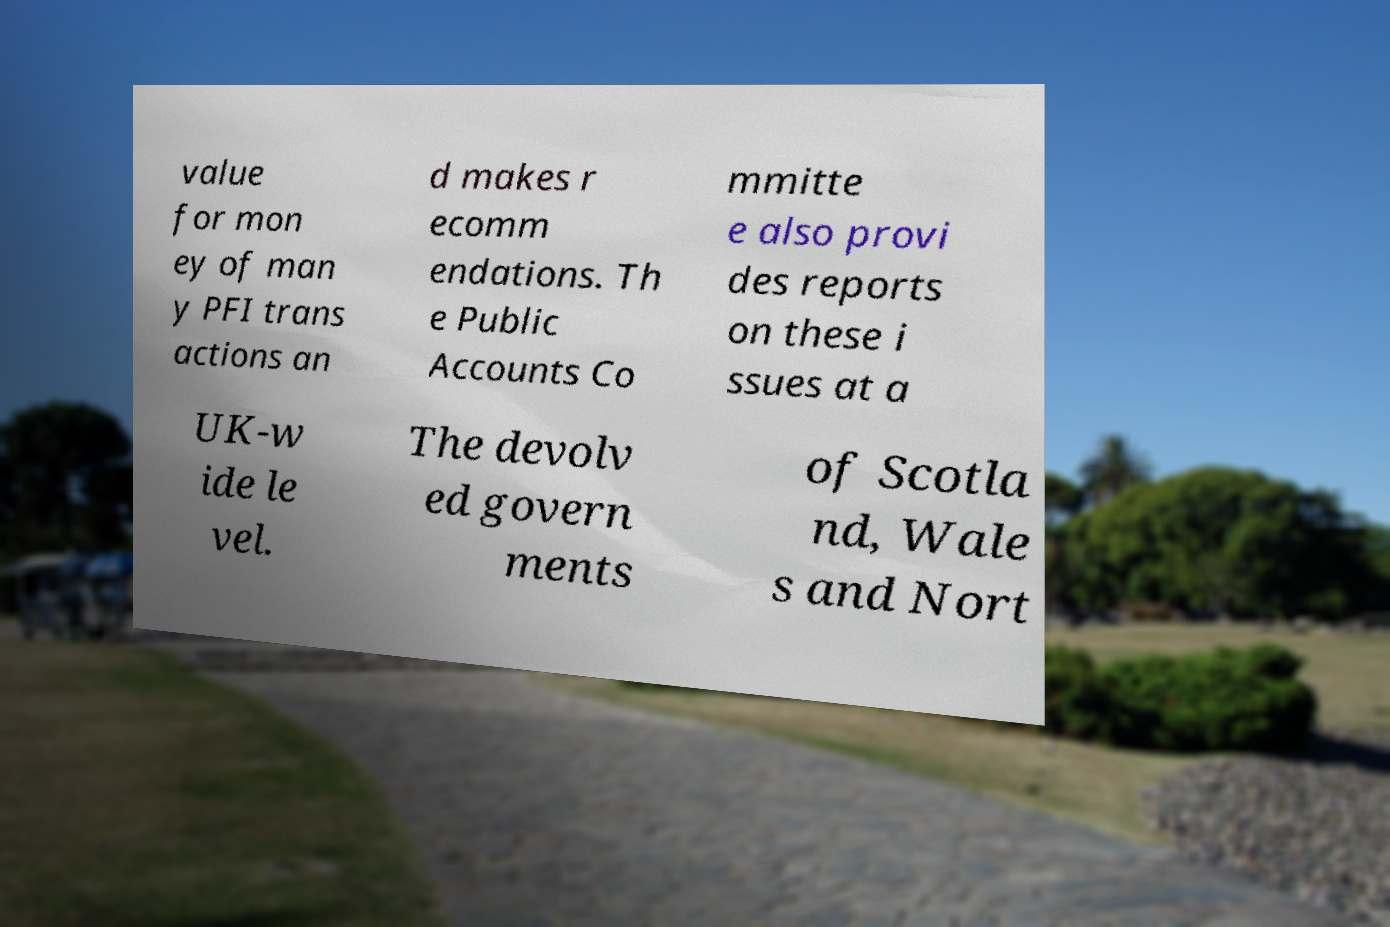Can you read and provide the text displayed in the image?This photo seems to have some interesting text. Can you extract and type it out for me? value for mon ey of man y PFI trans actions an d makes r ecomm endations. Th e Public Accounts Co mmitte e also provi des reports on these i ssues at a UK-w ide le vel. The devolv ed govern ments of Scotla nd, Wale s and Nort 